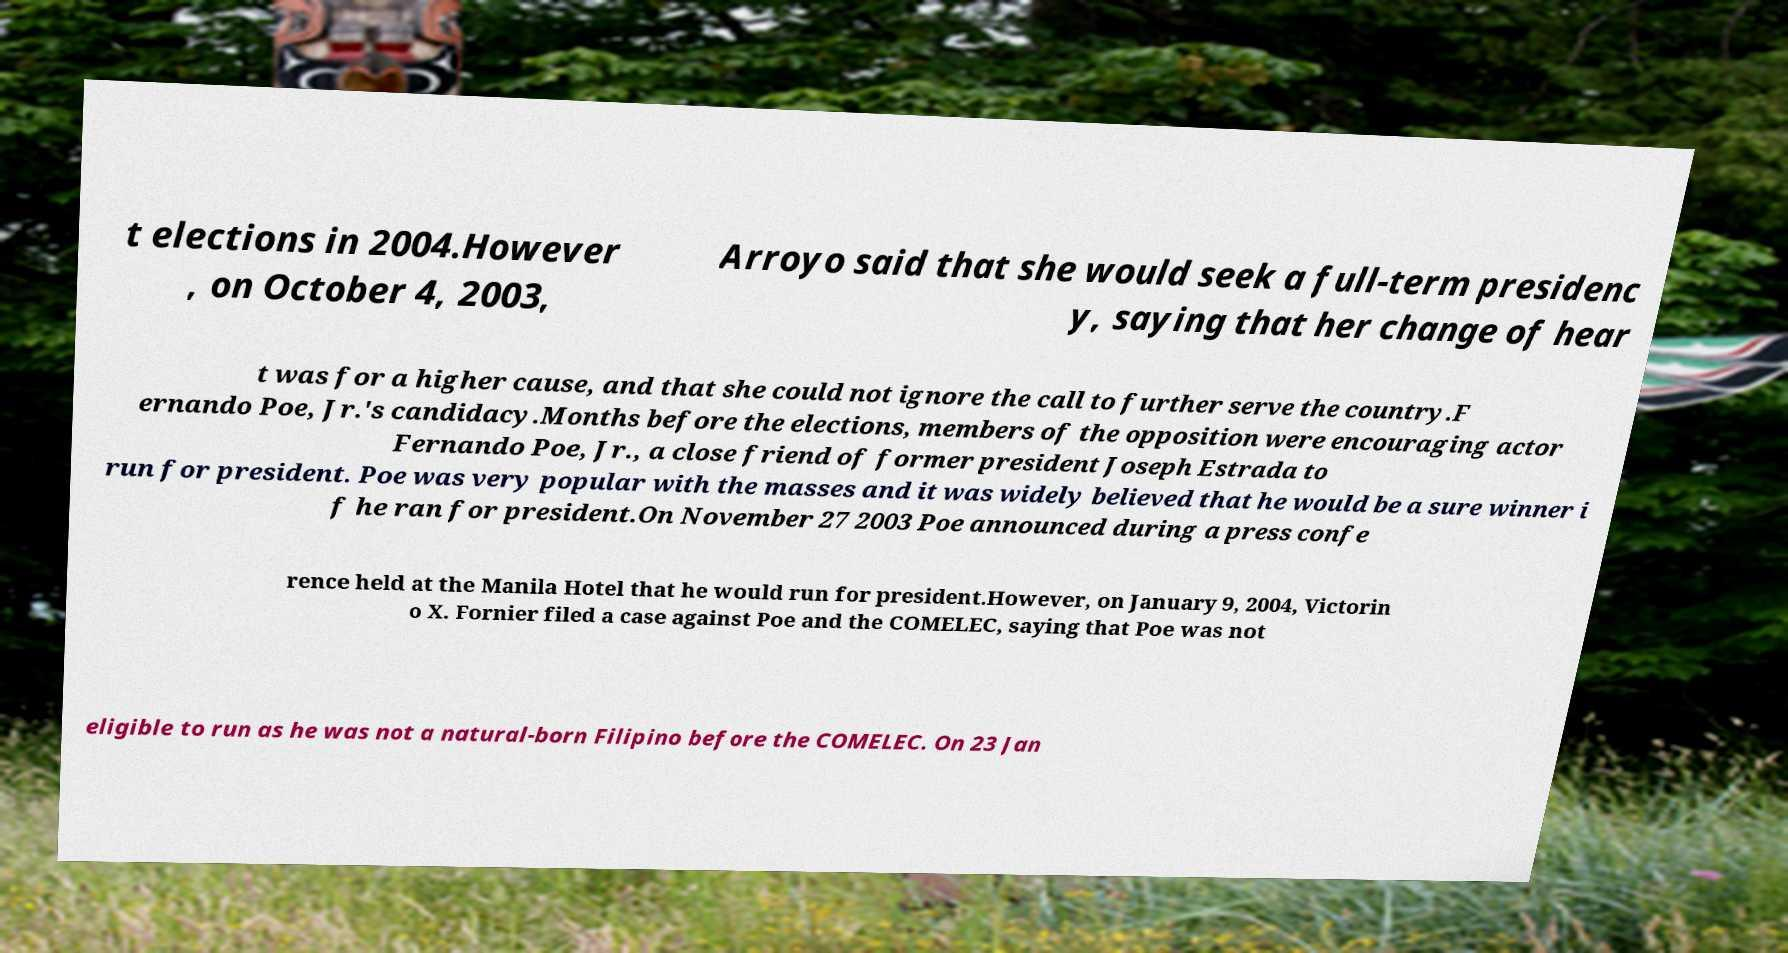Can you accurately transcribe the text from the provided image for me? t elections in 2004.However , on October 4, 2003, Arroyo said that she would seek a full-term presidenc y, saying that her change of hear t was for a higher cause, and that she could not ignore the call to further serve the country.F ernando Poe, Jr.'s candidacy.Months before the elections, members of the opposition were encouraging actor Fernando Poe, Jr., a close friend of former president Joseph Estrada to run for president. Poe was very popular with the masses and it was widely believed that he would be a sure winner i f he ran for president.On November 27 2003 Poe announced during a press confe rence held at the Manila Hotel that he would run for president.However, on January 9, 2004, Victorin o X. Fornier filed a case against Poe and the COMELEC, saying that Poe was not eligible to run as he was not a natural-born Filipino before the COMELEC. On 23 Jan 